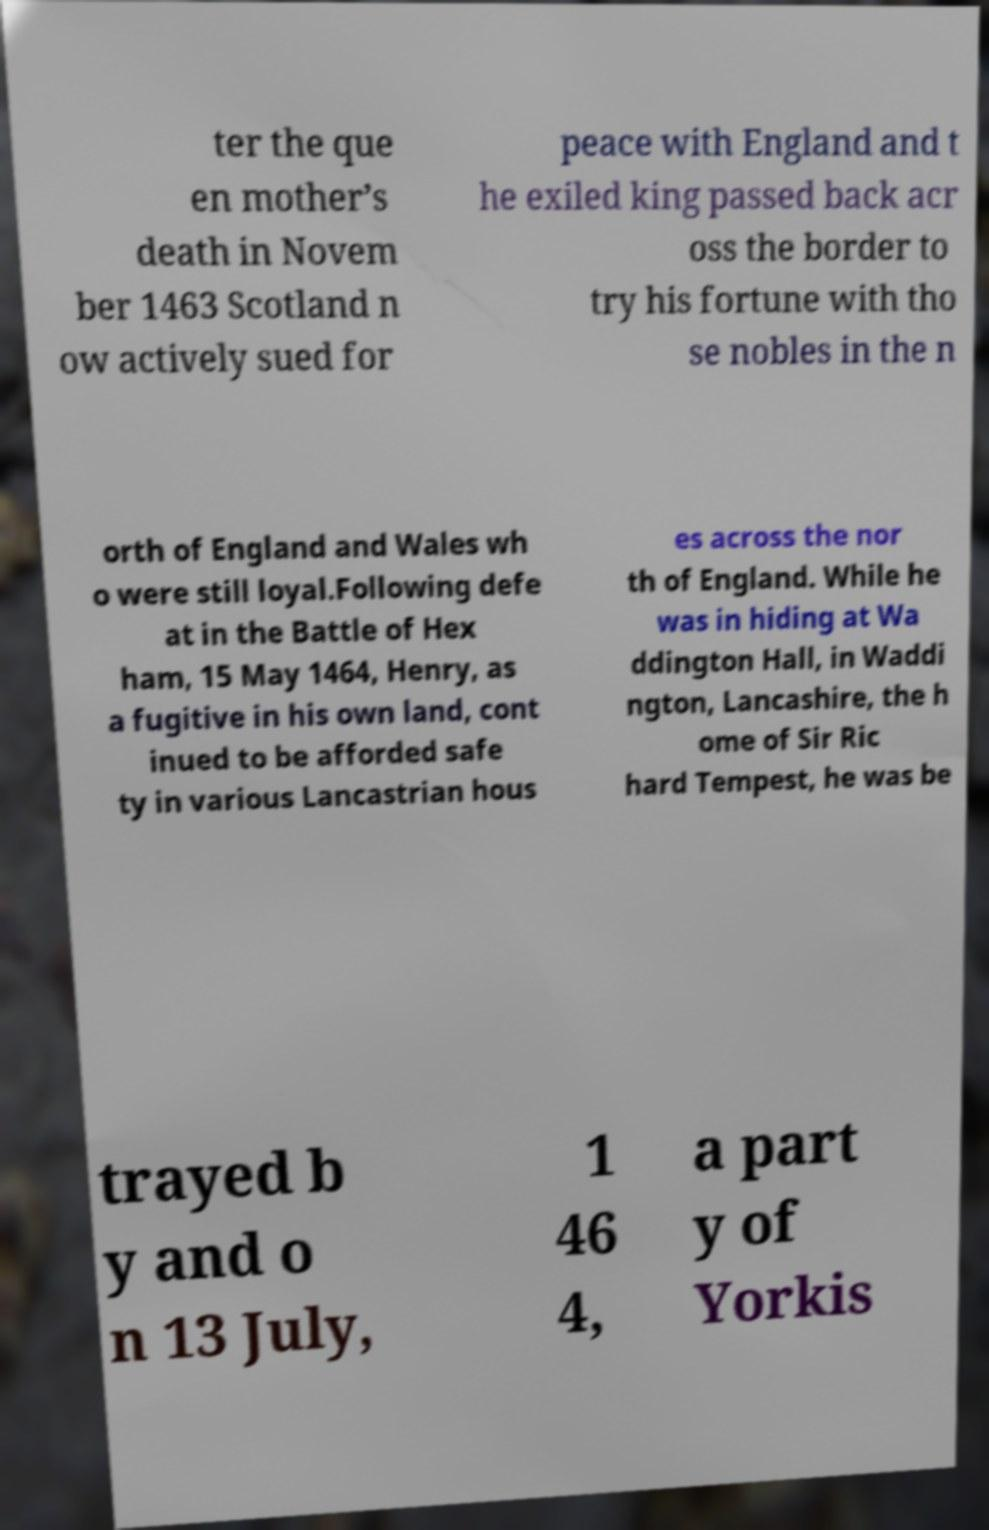Could you assist in decoding the text presented in this image and type it out clearly? ter the que en mother’s death in Novem ber 1463 Scotland n ow actively sued for peace with England and t he exiled king passed back acr oss the border to try his fortune with tho se nobles in the n orth of England and Wales wh o were still loyal.Following defe at in the Battle of Hex ham, 15 May 1464, Henry, as a fugitive in his own land, cont inued to be afforded safe ty in various Lancastrian hous es across the nor th of England. While he was in hiding at Wa ddington Hall, in Waddi ngton, Lancashire, the h ome of Sir Ric hard Tempest, he was be trayed b y and o n 13 July, 1 46 4, a part y of Yorkis 